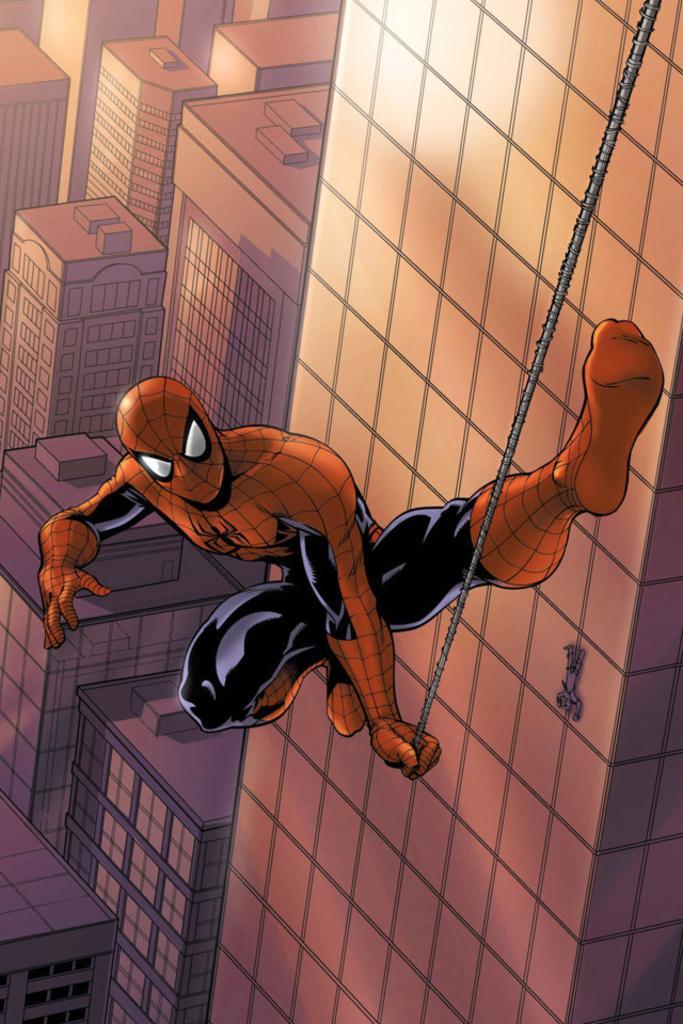How would you summarize this image in a sentence or two? It is an animated image,there is a spider man holding a rope and behind him there are many buildings. 